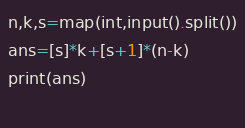<code> <loc_0><loc_0><loc_500><loc_500><_Python_>n,k,s=map(int,input().split())
ans=[s]*k+[s+1]*(n-k)
print(ans)
  </code> 